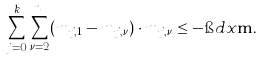<formula> <loc_0><loc_0><loc_500><loc_500>\sum _ { j = 0 } ^ { k } \sum _ { \nu = 2 } ^ { n _ { j } } ( m _ { j , 1 } - m _ { j , \nu } ) \cdot m _ { j , \nu } \leq - \i d x \mathbf m .</formula> 